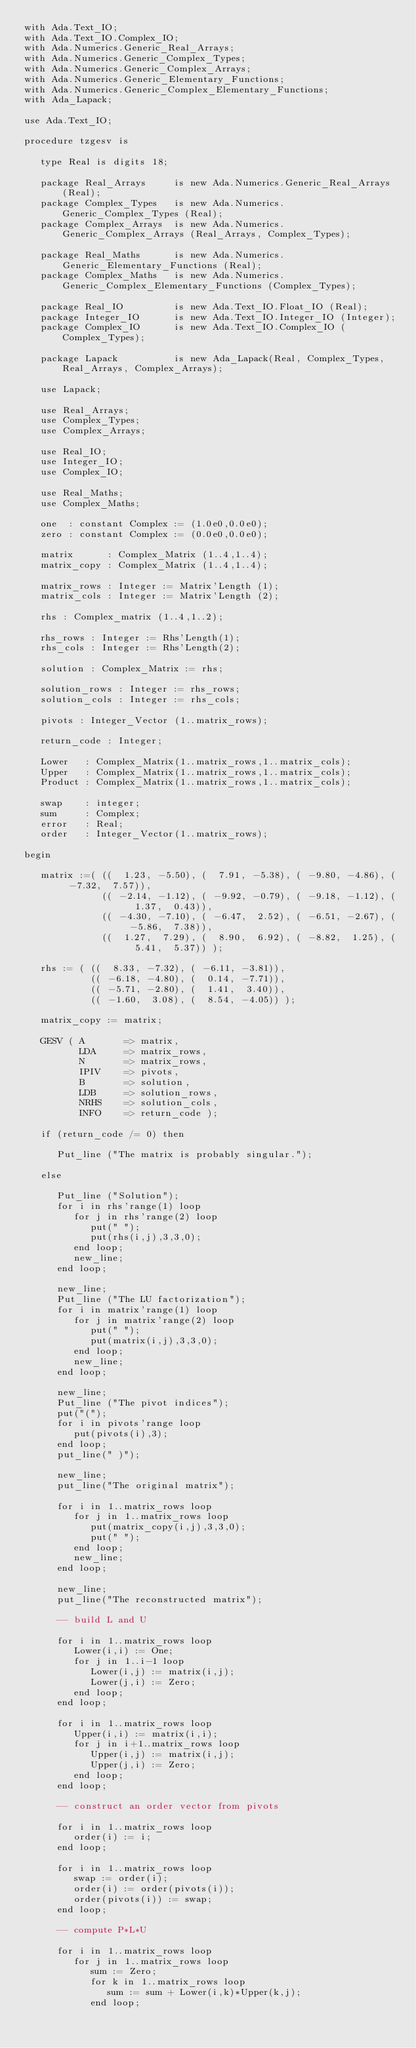<code> <loc_0><loc_0><loc_500><loc_500><_Ada_>with Ada.Text_IO; 
with Ada.Text_IO.Complex_IO;
with Ada.Numerics.Generic_Real_Arrays;
with Ada.Numerics.Generic_Complex_Types;
with Ada.Numerics.Generic_Complex_Arrays;
with Ada.Numerics.Generic_Elementary_Functions;
with Ada.Numerics.Generic_Complex_Elementary_Functions;
with Ada_Lapack;

use Ada.Text_IO;

procedure tzgesv is
   
   type Real is digits 18;

   package Real_Arrays     is new Ada.Numerics.Generic_Real_Arrays (Real);
   package Complex_Types   is new Ada.Numerics.Generic_Complex_Types (Real);
   package Complex_Arrays  is new Ada.Numerics.Generic_Complex_Arrays (Real_Arrays, Complex_Types);
   
   package Real_Maths      is new Ada.Numerics.Generic_Elementary_Functions (Real);
   package Complex_Maths   is new Ada.Numerics.Generic_Complex_Elementary_Functions (Complex_Types);

   package Real_IO         is new Ada.Text_IO.Float_IO (Real);
   package Integer_IO      is new Ada.Text_IO.Integer_IO (Integer);
   package Complex_IO      is new Ada.Text_IO.Complex_IO (Complex_Types);

   package Lapack          is new Ada_Lapack(Real, Complex_Types, Real_Arrays, Complex_Arrays);
      
   use Lapack;
   
   use Real_Arrays;
   use Complex_Types;
   use Complex_Arrays;
   
   use Real_IO;
   use Integer_IO;
   use Complex_IO;
   
   use Real_Maths;
   use Complex_Maths;
   
   one  : constant Complex := (1.0e0,0.0e0);
   zero : constant Complex := (0.0e0,0.0e0);
   
   matrix      : Complex_Matrix (1..4,1..4);
   matrix_copy : Complex_Matrix (1..4,1..4);
   
   matrix_rows : Integer := Matrix'Length (1);
   matrix_cols : Integer := Matrix'Length (2);
   
   rhs : Complex_matrix (1..4,1..2);
   
   rhs_rows : Integer := Rhs'Length(1);
   rhs_cols : Integer := Rhs'Length(2);
   
   solution : Complex_Matrix := rhs;
   
   solution_rows : Integer := rhs_rows;
   solution_cols : Integer := rhs_cols;
   
   pivots : Integer_Vector (1..matrix_rows);
   
   return_code : Integer;

   Lower   : Complex_Matrix(1..matrix_rows,1..matrix_cols);
   Upper   : Complex_Matrix(1..matrix_rows,1..matrix_cols);
   Product : Complex_Matrix(1..matrix_rows,1..matrix_cols);
   
   swap    : integer;
   sum     : Complex;
   error   : Real;
   order   : Integer_Vector(1..matrix_rows);

begin
   
   matrix :=( ((  1.23, -5.50), (  7.91, -5.38), ( -9.80, -4.86), ( -7.32,  7.57)),
              (( -2.14, -1.12), ( -9.92, -0.79), ( -9.18, -1.12), (  1.37,  0.43)),
              (( -4.30, -7.10), ( -6.47,  2.52), ( -6.51, -2.67), ( -5.86,  7.38)),
              ((  1.27,  7.29), (  8.90,  6.92), ( -8.82,  1.25), (  5.41,  5.37)) );
  
   rhs := ( ((  8.33, -7.32), ( -6.11, -3.81)),
            (( -6.18, -4.80), (  0.14, -7.71)),
            (( -5.71, -2.80), (  1.41,  3.40)),
            (( -1.60,  3.08), (  8.54, -4.05)) );
          
   matrix_copy := matrix;
   
   GESV ( A       => matrix,
          LDA     => matrix_rows,
          N       => matrix_rows,
          IPIV    => pivots,
          B       => solution,
          LDB     => solution_rows,
          NRHS    => solution_cols,
          INFO    => return_code );
      
   if (return_code /= 0) then

      Put_line ("The matrix is probably singular.");

   else
      
      Put_line ("Solution");
      for i in rhs'range(1) loop
         for j in rhs'range(2) loop
            put(" ");
            put(rhs(i,j),3,3,0);
         end loop;
         new_line;
      end loop;
         
      new_line;
      Put_line ("The LU factorization");
      for i in matrix'range(1) loop
         for j in matrix'range(2) loop
            put(" ");
            put(matrix(i,j),3,3,0);
         end loop;
         new_line;
      end loop;
         
      new_line;
      Put_line ("The pivot indices");
      put("(");
      for i in pivots'range loop
         put(pivots(i),3);
      end loop;
      put_line(" )");
      
      new_line;
      put_line("The original matrix");
      
      for i in 1..matrix_rows loop
         for j in 1..matrix_rows loop
            put(matrix_copy(i,j),3,3,0);
            put(" ");
         end loop;
         new_line;
      end loop;
         
      new_line;
      put_line("The reconstructed matrix");
      
      -- build L and U
      
      for i in 1..matrix_rows loop
         Lower(i,i) := One;
         for j in 1..i-1 loop
            Lower(i,j) := matrix(i,j);
            Lower(j,i) := Zero;
         end loop;
      end loop;
         
      for i in 1..matrix_rows loop
         Upper(i,i) := matrix(i,i);
         for j in i+1..matrix_rows loop
            Upper(i,j) := matrix(i,j);
            Upper(j,i) := Zero;
         end loop;
      end loop;
      
      -- construct an order vector from pivots
      
      for i in 1..matrix_rows loop
         order(i) := i;
      end loop;
         
      for i in 1..matrix_rows loop
         swap := order(i);
         order(i) := order(pivots(i));
         order(pivots(i)) := swap;
      end loop;
      
      -- compute P*L*U
      
      for i in 1..matrix_rows loop
         for j in 1..matrix_rows loop
            sum := Zero;
            for k in 1..matrix_rows loop
               sum := sum + Lower(i,k)*Upper(k,j);
            end loop;</code> 